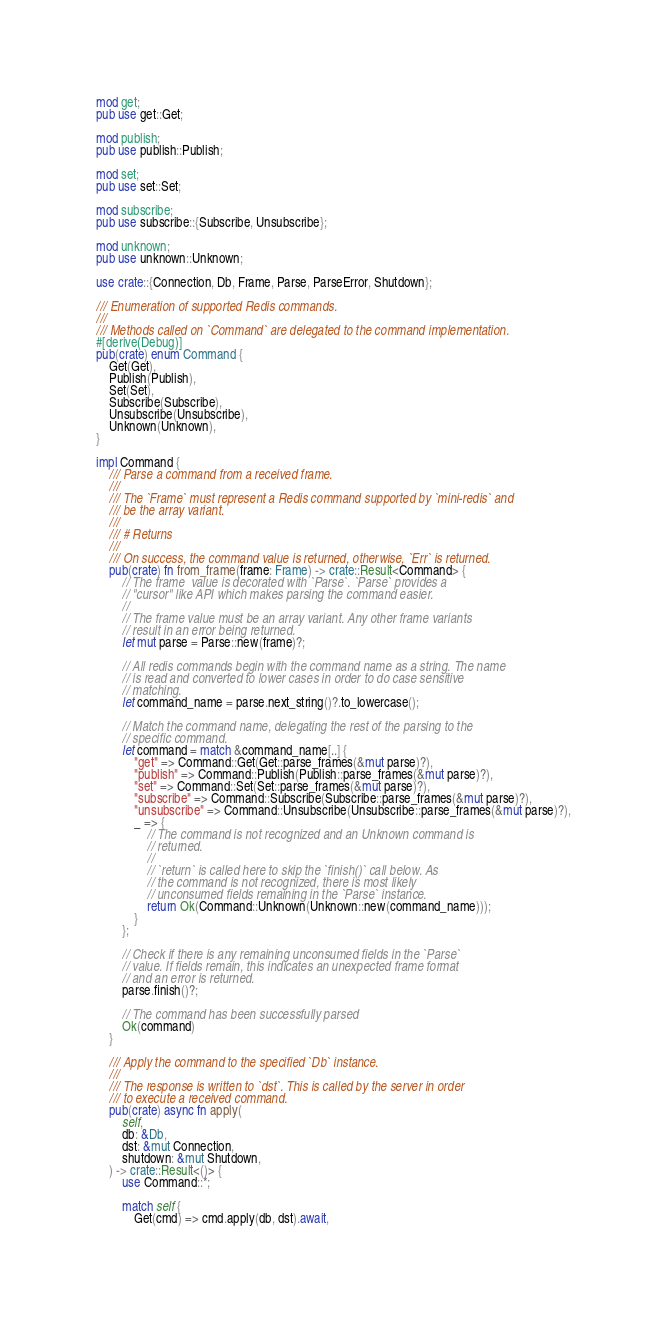Convert code to text. <code><loc_0><loc_0><loc_500><loc_500><_Rust_>mod get;
pub use get::Get;

mod publish;
pub use publish::Publish;

mod set;
pub use set::Set;

mod subscribe;
pub use subscribe::{Subscribe, Unsubscribe};

mod unknown;
pub use unknown::Unknown;

use crate::{Connection, Db, Frame, Parse, ParseError, Shutdown};

/// Enumeration of supported Redis commands.
///
/// Methods called on `Command` are delegated to the command implementation.
#[derive(Debug)]
pub(crate) enum Command {
    Get(Get),
    Publish(Publish),
    Set(Set),
    Subscribe(Subscribe),
    Unsubscribe(Unsubscribe),
    Unknown(Unknown),
}

impl Command {
    /// Parse a command from a received frame.
    ///
    /// The `Frame` must represent a Redis command supported by `mini-redis` and
    /// be the array variant.
    ///
    /// # Returns
    ///
    /// On success, the command value is returned, otherwise, `Err` is returned.
    pub(crate) fn from_frame(frame: Frame) -> crate::Result<Command> {
        // The frame  value is decorated with `Parse`. `Parse` provides a
        // "cursor" like API which makes parsing the command easier.
        //
        // The frame value must be an array variant. Any other frame variants
        // result in an error being returned.
        let mut parse = Parse::new(frame)?;

        // All redis commands begin with the command name as a string. The name
        // is read and converted to lower cases in order to do case sensitive
        // matching.
        let command_name = parse.next_string()?.to_lowercase();

        // Match the command name, delegating the rest of the parsing to the
        // specific command.
        let command = match &command_name[..] {
            "get" => Command::Get(Get::parse_frames(&mut parse)?),
            "publish" => Command::Publish(Publish::parse_frames(&mut parse)?),
            "set" => Command::Set(Set::parse_frames(&mut parse)?),
            "subscribe" => Command::Subscribe(Subscribe::parse_frames(&mut parse)?),
            "unsubscribe" => Command::Unsubscribe(Unsubscribe::parse_frames(&mut parse)?),
            _ => {
                // The command is not recognized and an Unknown command is
                // returned.
                //
                // `return` is called here to skip the `finish()` call below. As
                // the command is not recognized, there is most likely
                // unconsumed fields remaining in the `Parse` instance.
                return Ok(Command::Unknown(Unknown::new(command_name)));
            }
        };

        // Check if there is any remaining unconsumed fields in the `Parse`
        // value. If fields remain, this indicates an unexpected frame format
        // and an error is returned.
        parse.finish()?;

        // The command has been successfully parsed
        Ok(command)
    }

    /// Apply the command to the specified `Db` instance.
    ///
    /// The response is written to `dst`. This is called by the server in order
    /// to execute a received command.
    pub(crate) async fn apply(
        self,
        db: &Db,
        dst: &mut Connection,
        shutdown: &mut Shutdown,
    ) -> crate::Result<()> {
        use Command::*;

        match self {
            Get(cmd) => cmd.apply(db, dst).await,</code> 